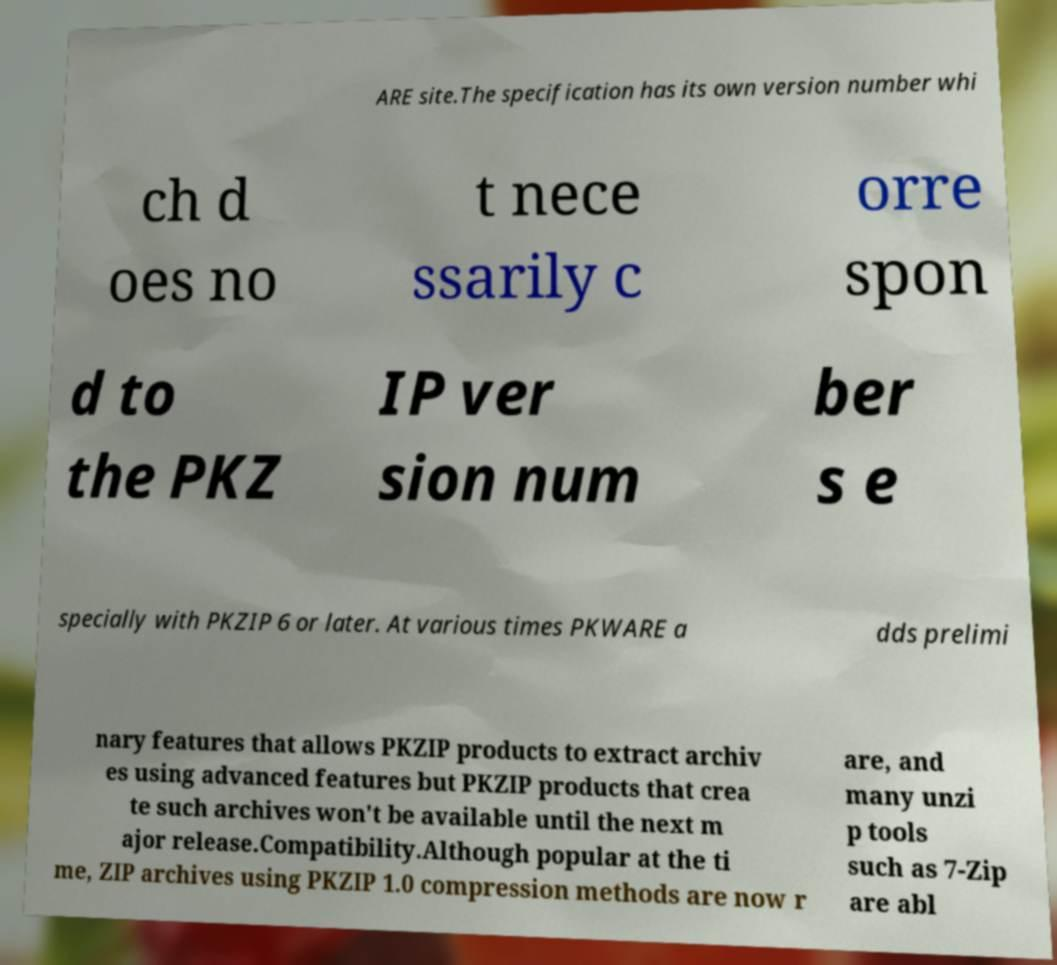Can you accurately transcribe the text from the provided image for me? ARE site.The specification has its own version number whi ch d oes no t nece ssarily c orre spon d to the PKZ IP ver sion num ber s e specially with PKZIP 6 or later. At various times PKWARE a dds prelimi nary features that allows PKZIP products to extract archiv es using advanced features but PKZIP products that crea te such archives won't be available until the next m ajor release.Compatibility.Although popular at the ti me, ZIP archives using PKZIP 1.0 compression methods are now r are, and many unzi p tools such as 7-Zip are abl 